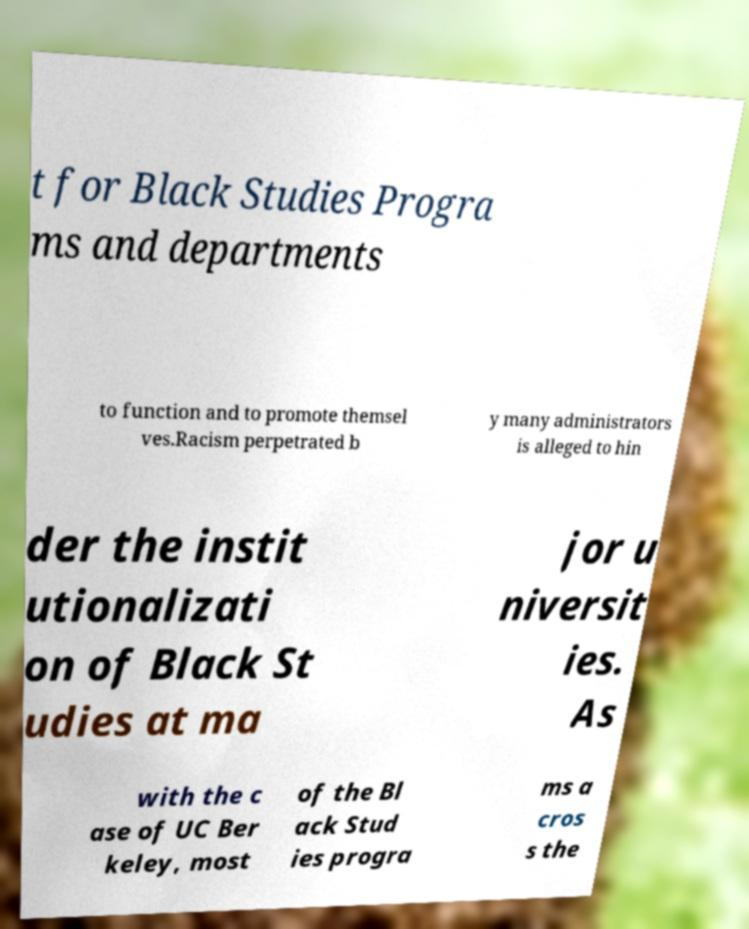What messages or text are displayed in this image? I need them in a readable, typed format. t for Black Studies Progra ms and departments to function and to promote themsel ves.Racism perpetrated b y many administrators is alleged to hin der the instit utionalizati on of Black St udies at ma jor u niversit ies. As with the c ase of UC Ber keley, most of the Bl ack Stud ies progra ms a cros s the 